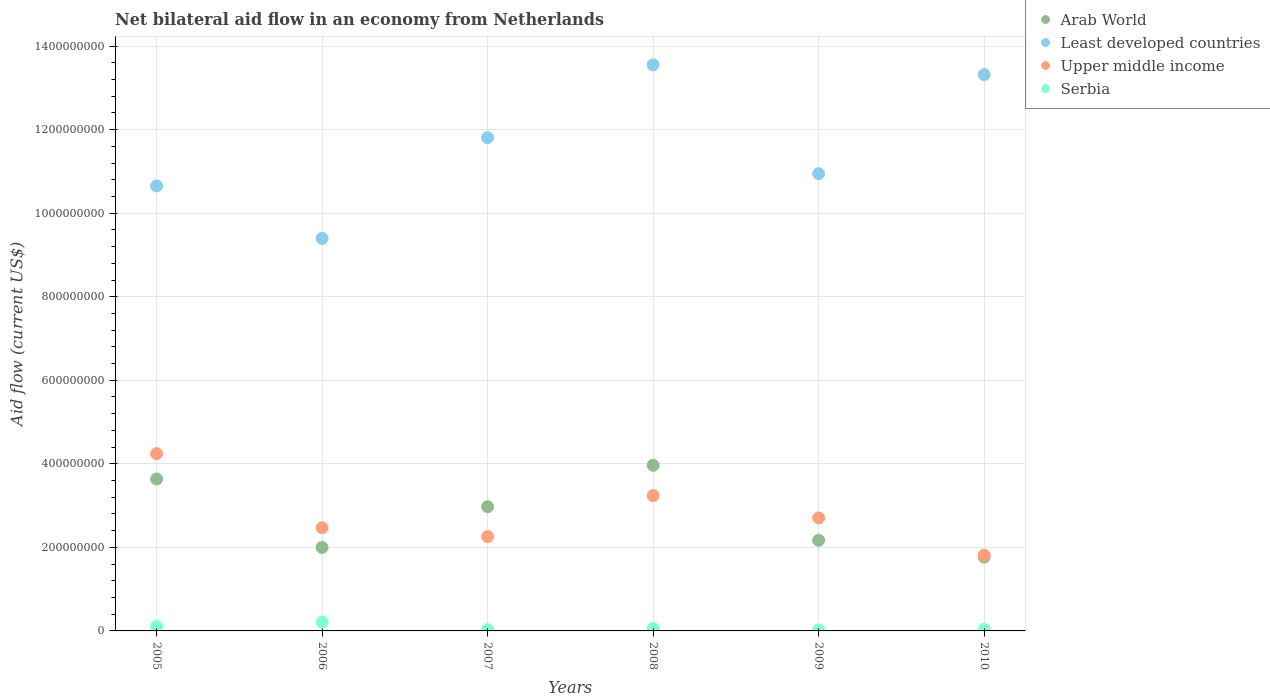Is the number of dotlines equal to the number of legend labels?
Give a very brief answer. Yes. What is the net bilateral aid flow in Serbia in 2005?
Offer a terse response. 1.08e+07. Across all years, what is the maximum net bilateral aid flow in Least developed countries?
Provide a short and direct response. 1.36e+09. Across all years, what is the minimum net bilateral aid flow in Least developed countries?
Offer a very short reply. 9.40e+08. In which year was the net bilateral aid flow in Arab World maximum?
Your response must be concise. 2008. In which year was the net bilateral aid flow in Upper middle income minimum?
Your answer should be compact. 2010. What is the total net bilateral aid flow in Arab World in the graph?
Your answer should be compact. 1.65e+09. What is the difference between the net bilateral aid flow in Least developed countries in 2008 and that in 2009?
Your answer should be compact. 2.61e+08. What is the difference between the net bilateral aid flow in Serbia in 2006 and the net bilateral aid flow in Least developed countries in 2005?
Your answer should be very brief. -1.04e+09. What is the average net bilateral aid flow in Upper middle income per year?
Provide a short and direct response. 2.79e+08. In the year 2007, what is the difference between the net bilateral aid flow in Arab World and net bilateral aid flow in Least developed countries?
Make the answer very short. -8.83e+08. What is the ratio of the net bilateral aid flow in Arab World in 2009 to that in 2010?
Your answer should be compact. 1.23. Is the net bilateral aid flow in Serbia in 2006 less than that in 2007?
Provide a succinct answer. No. Is the difference between the net bilateral aid flow in Arab World in 2008 and 2009 greater than the difference between the net bilateral aid flow in Least developed countries in 2008 and 2009?
Your answer should be very brief. No. What is the difference between the highest and the second highest net bilateral aid flow in Upper middle income?
Offer a very short reply. 1.00e+08. What is the difference between the highest and the lowest net bilateral aid flow in Least developed countries?
Your response must be concise. 4.16e+08. Is the sum of the net bilateral aid flow in Upper middle income in 2007 and 2008 greater than the maximum net bilateral aid flow in Serbia across all years?
Your response must be concise. Yes. Is it the case that in every year, the sum of the net bilateral aid flow in Serbia and net bilateral aid flow in Arab World  is greater than the net bilateral aid flow in Upper middle income?
Offer a very short reply. No. Does the net bilateral aid flow in Serbia monotonically increase over the years?
Provide a short and direct response. No. How many dotlines are there?
Provide a short and direct response. 4. Does the graph contain grids?
Your response must be concise. Yes. Where does the legend appear in the graph?
Offer a very short reply. Top right. How many legend labels are there?
Ensure brevity in your answer.  4. What is the title of the graph?
Your answer should be compact. Net bilateral aid flow in an economy from Netherlands. What is the Aid flow (current US$) of Arab World in 2005?
Your answer should be compact. 3.64e+08. What is the Aid flow (current US$) of Least developed countries in 2005?
Your answer should be very brief. 1.07e+09. What is the Aid flow (current US$) in Upper middle income in 2005?
Your response must be concise. 4.24e+08. What is the Aid flow (current US$) in Serbia in 2005?
Offer a terse response. 1.08e+07. What is the Aid flow (current US$) of Arab World in 2006?
Keep it short and to the point. 2.00e+08. What is the Aid flow (current US$) of Least developed countries in 2006?
Ensure brevity in your answer.  9.40e+08. What is the Aid flow (current US$) of Upper middle income in 2006?
Your answer should be very brief. 2.47e+08. What is the Aid flow (current US$) of Serbia in 2006?
Your response must be concise. 2.13e+07. What is the Aid flow (current US$) in Arab World in 2007?
Ensure brevity in your answer.  2.97e+08. What is the Aid flow (current US$) of Least developed countries in 2007?
Offer a terse response. 1.18e+09. What is the Aid flow (current US$) of Upper middle income in 2007?
Offer a very short reply. 2.26e+08. What is the Aid flow (current US$) of Serbia in 2007?
Your answer should be very brief. 3.11e+06. What is the Aid flow (current US$) in Arab World in 2008?
Offer a terse response. 3.96e+08. What is the Aid flow (current US$) of Least developed countries in 2008?
Your answer should be very brief. 1.36e+09. What is the Aid flow (current US$) of Upper middle income in 2008?
Your answer should be compact. 3.24e+08. What is the Aid flow (current US$) in Serbia in 2008?
Offer a terse response. 6.06e+06. What is the Aid flow (current US$) in Arab World in 2009?
Offer a terse response. 2.17e+08. What is the Aid flow (current US$) of Least developed countries in 2009?
Keep it short and to the point. 1.09e+09. What is the Aid flow (current US$) of Upper middle income in 2009?
Give a very brief answer. 2.71e+08. What is the Aid flow (current US$) of Serbia in 2009?
Provide a succinct answer. 2.62e+06. What is the Aid flow (current US$) of Arab World in 2010?
Your answer should be compact. 1.77e+08. What is the Aid flow (current US$) in Least developed countries in 2010?
Give a very brief answer. 1.33e+09. What is the Aid flow (current US$) of Upper middle income in 2010?
Your answer should be very brief. 1.81e+08. What is the Aid flow (current US$) in Serbia in 2010?
Give a very brief answer. 3.78e+06. Across all years, what is the maximum Aid flow (current US$) in Arab World?
Offer a terse response. 3.96e+08. Across all years, what is the maximum Aid flow (current US$) in Least developed countries?
Your answer should be compact. 1.36e+09. Across all years, what is the maximum Aid flow (current US$) of Upper middle income?
Provide a short and direct response. 4.24e+08. Across all years, what is the maximum Aid flow (current US$) of Serbia?
Offer a very short reply. 2.13e+07. Across all years, what is the minimum Aid flow (current US$) of Arab World?
Offer a terse response. 1.77e+08. Across all years, what is the minimum Aid flow (current US$) in Least developed countries?
Provide a short and direct response. 9.40e+08. Across all years, what is the minimum Aid flow (current US$) in Upper middle income?
Offer a very short reply. 1.81e+08. Across all years, what is the minimum Aid flow (current US$) in Serbia?
Your answer should be very brief. 2.62e+06. What is the total Aid flow (current US$) in Arab World in the graph?
Give a very brief answer. 1.65e+09. What is the total Aid flow (current US$) in Least developed countries in the graph?
Keep it short and to the point. 6.97e+09. What is the total Aid flow (current US$) in Upper middle income in the graph?
Give a very brief answer. 1.67e+09. What is the total Aid flow (current US$) in Serbia in the graph?
Your answer should be compact. 4.76e+07. What is the difference between the Aid flow (current US$) in Arab World in 2005 and that in 2006?
Offer a very short reply. 1.64e+08. What is the difference between the Aid flow (current US$) of Least developed countries in 2005 and that in 2006?
Your answer should be very brief. 1.26e+08. What is the difference between the Aid flow (current US$) in Upper middle income in 2005 and that in 2006?
Make the answer very short. 1.77e+08. What is the difference between the Aid flow (current US$) of Serbia in 2005 and that in 2006?
Your answer should be compact. -1.06e+07. What is the difference between the Aid flow (current US$) in Arab World in 2005 and that in 2007?
Your answer should be very brief. 6.62e+07. What is the difference between the Aid flow (current US$) of Least developed countries in 2005 and that in 2007?
Provide a succinct answer. -1.15e+08. What is the difference between the Aid flow (current US$) in Upper middle income in 2005 and that in 2007?
Your answer should be very brief. 1.99e+08. What is the difference between the Aid flow (current US$) in Serbia in 2005 and that in 2007?
Make the answer very short. 7.64e+06. What is the difference between the Aid flow (current US$) in Arab World in 2005 and that in 2008?
Provide a short and direct response. -3.29e+07. What is the difference between the Aid flow (current US$) of Least developed countries in 2005 and that in 2008?
Offer a very short reply. -2.90e+08. What is the difference between the Aid flow (current US$) in Upper middle income in 2005 and that in 2008?
Make the answer very short. 1.00e+08. What is the difference between the Aid flow (current US$) in Serbia in 2005 and that in 2008?
Ensure brevity in your answer.  4.69e+06. What is the difference between the Aid flow (current US$) in Arab World in 2005 and that in 2009?
Make the answer very short. 1.47e+08. What is the difference between the Aid flow (current US$) in Least developed countries in 2005 and that in 2009?
Your response must be concise. -2.94e+07. What is the difference between the Aid flow (current US$) of Upper middle income in 2005 and that in 2009?
Make the answer very short. 1.54e+08. What is the difference between the Aid flow (current US$) of Serbia in 2005 and that in 2009?
Your response must be concise. 8.13e+06. What is the difference between the Aid flow (current US$) in Arab World in 2005 and that in 2010?
Make the answer very short. 1.87e+08. What is the difference between the Aid flow (current US$) in Least developed countries in 2005 and that in 2010?
Keep it short and to the point. -2.66e+08. What is the difference between the Aid flow (current US$) in Upper middle income in 2005 and that in 2010?
Your answer should be compact. 2.43e+08. What is the difference between the Aid flow (current US$) in Serbia in 2005 and that in 2010?
Your response must be concise. 6.97e+06. What is the difference between the Aid flow (current US$) in Arab World in 2006 and that in 2007?
Provide a succinct answer. -9.76e+07. What is the difference between the Aid flow (current US$) in Least developed countries in 2006 and that in 2007?
Make the answer very short. -2.41e+08. What is the difference between the Aid flow (current US$) of Upper middle income in 2006 and that in 2007?
Your answer should be very brief. 2.12e+07. What is the difference between the Aid flow (current US$) of Serbia in 2006 and that in 2007?
Offer a terse response. 1.82e+07. What is the difference between the Aid flow (current US$) of Arab World in 2006 and that in 2008?
Your answer should be compact. -1.97e+08. What is the difference between the Aid flow (current US$) of Least developed countries in 2006 and that in 2008?
Ensure brevity in your answer.  -4.16e+08. What is the difference between the Aid flow (current US$) in Upper middle income in 2006 and that in 2008?
Your answer should be very brief. -7.70e+07. What is the difference between the Aid flow (current US$) of Serbia in 2006 and that in 2008?
Provide a succinct answer. 1.52e+07. What is the difference between the Aid flow (current US$) in Arab World in 2006 and that in 2009?
Ensure brevity in your answer.  -1.71e+07. What is the difference between the Aid flow (current US$) in Least developed countries in 2006 and that in 2009?
Your response must be concise. -1.55e+08. What is the difference between the Aid flow (current US$) in Upper middle income in 2006 and that in 2009?
Ensure brevity in your answer.  -2.36e+07. What is the difference between the Aid flow (current US$) in Serbia in 2006 and that in 2009?
Ensure brevity in your answer.  1.87e+07. What is the difference between the Aid flow (current US$) in Arab World in 2006 and that in 2010?
Make the answer very short. 2.32e+07. What is the difference between the Aid flow (current US$) in Least developed countries in 2006 and that in 2010?
Offer a very short reply. -3.92e+08. What is the difference between the Aid flow (current US$) in Upper middle income in 2006 and that in 2010?
Provide a succinct answer. 6.58e+07. What is the difference between the Aid flow (current US$) of Serbia in 2006 and that in 2010?
Make the answer very short. 1.75e+07. What is the difference between the Aid flow (current US$) in Arab World in 2007 and that in 2008?
Keep it short and to the point. -9.91e+07. What is the difference between the Aid flow (current US$) in Least developed countries in 2007 and that in 2008?
Give a very brief answer. -1.74e+08. What is the difference between the Aid flow (current US$) of Upper middle income in 2007 and that in 2008?
Offer a very short reply. -9.82e+07. What is the difference between the Aid flow (current US$) in Serbia in 2007 and that in 2008?
Your response must be concise. -2.95e+06. What is the difference between the Aid flow (current US$) of Arab World in 2007 and that in 2009?
Ensure brevity in your answer.  8.05e+07. What is the difference between the Aid flow (current US$) of Least developed countries in 2007 and that in 2009?
Your answer should be compact. 8.61e+07. What is the difference between the Aid flow (current US$) in Upper middle income in 2007 and that in 2009?
Your answer should be very brief. -4.48e+07. What is the difference between the Aid flow (current US$) of Arab World in 2007 and that in 2010?
Make the answer very short. 1.21e+08. What is the difference between the Aid flow (current US$) in Least developed countries in 2007 and that in 2010?
Provide a short and direct response. -1.51e+08. What is the difference between the Aid flow (current US$) in Upper middle income in 2007 and that in 2010?
Your answer should be very brief. 4.46e+07. What is the difference between the Aid flow (current US$) in Serbia in 2007 and that in 2010?
Make the answer very short. -6.70e+05. What is the difference between the Aid flow (current US$) in Arab World in 2008 and that in 2009?
Offer a terse response. 1.80e+08. What is the difference between the Aid flow (current US$) in Least developed countries in 2008 and that in 2009?
Offer a very short reply. 2.61e+08. What is the difference between the Aid flow (current US$) in Upper middle income in 2008 and that in 2009?
Keep it short and to the point. 5.34e+07. What is the difference between the Aid flow (current US$) in Serbia in 2008 and that in 2009?
Your answer should be very brief. 3.44e+06. What is the difference between the Aid flow (current US$) in Arab World in 2008 and that in 2010?
Keep it short and to the point. 2.20e+08. What is the difference between the Aid flow (current US$) of Least developed countries in 2008 and that in 2010?
Provide a short and direct response. 2.34e+07. What is the difference between the Aid flow (current US$) in Upper middle income in 2008 and that in 2010?
Your answer should be compact. 1.43e+08. What is the difference between the Aid flow (current US$) of Serbia in 2008 and that in 2010?
Your answer should be very brief. 2.28e+06. What is the difference between the Aid flow (current US$) in Arab World in 2009 and that in 2010?
Your answer should be very brief. 4.02e+07. What is the difference between the Aid flow (current US$) in Least developed countries in 2009 and that in 2010?
Give a very brief answer. -2.37e+08. What is the difference between the Aid flow (current US$) of Upper middle income in 2009 and that in 2010?
Ensure brevity in your answer.  8.93e+07. What is the difference between the Aid flow (current US$) in Serbia in 2009 and that in 2010?
Provide a short and direct response. -1.16e+06. What is the difference between the Aid flow (current US$) of Arab World in 2005 and the Aid flow (current US$) of Least developed countries in 2006?
Offer a terse response. -5.76e+08. What is the difference between the Aid flow (current US$) of Arab World in 2005 and the Aid flow (current US$) of Upper middle income in 2006?
Keep it short and to the point. 1.17e+08. What is the difference between the Aid flow (current US$) in Arab World in 2005 and the Aid flow (current US$) in Serbia in 2006?
Offer a very short reply. 3.42e+08. What is the difference between the Aid flow (current US$) in Least developed countries in 2005 and the Aid flow (current US$) in Upper middle income in 2006?
Your response must be concise. 8.18e+08. What is the difference between the Aid flow (current US$) in Least developed countries in 2005 and the Aid flow (current US$) in Serbia in 2006?
Ensure brevity in your answer.  1.04e+09. What is the difference between the Aid flow (current US$) of Upper middle income in 2005 and the Aid flow (current US$) of Serbia in 2006?
Offer a terse response. 4.03e+08. What is the difference between the Aid flow (current US$) in Arab World in 2005 and the Aid flow (current US$) in Least developed countries in 2007?
Your response must be concise. -8.17e+08. What is the difference between the Aid flow (current US$) in Arab World in 2005 and the Aid flow (current US$) in Upper middle income in 2007?
Offer a terse response. 1.38e+08. What is the difference between the Aid flow (current US$) of Arab World in 2005 and the Aid flow (current US$) of Serbia in 2007?
Your response must be concise. 3.60e+08. What is the difference between the Aid flow (current US$) of Least developed countries in 2005 and the Aid flow (current US$) of Upper middle income in 2007?
Offer a terse response. 8.39e+08. What is the difference between the Aid flow (current US$) in Least developed countries in 2005 and the Aid flow (current US$) in Serbia in 2007?
Your answer should be very brief. 1.06e+09. What is the difference between the Aid flow (current US$) of Upper middle income in 2005 and the Aid flow (current US$) of Serbia in 2007?
Make the answer very short. 4.21e+08. What is the difference between the Aid flow (current US$) of Arab World in 2005 and the Aid flow (current US$) of Least developed countries in 2008?
Your answer should be compact. -9.92e+08. What is the difference between the Aid flow (current US$) of Arab World in 2005 and the Aid flow (current US$) of Upper middle income in 2008?
Offer a terse response. 3.95e+07. What is the difference between the Aid flow (current US$) of Arab World in 2005 and the Aid flow (current US$) of Serbia in 2008?
Offer a terse response. 3.58e+08. What is the difference between the Aid flow (current US$) in Least developed countries in 2005 and the Aid flow (current US$) in Upper middle income in 2008?
Your answer should be compact. 7.41e+08. What is the difference between the Aid flow (current US$) of Least developed countries in 2005 and the Aid flow (current US$) of Serbia in 2008?
Make the answer very short. 1.06e+09. What is the difference between the Aid flow (current US$) of Upper middle income in 2005 and the Aid flow (current US$) of Serbia in 2008?
Give a very brief answer. 4.18e+08. What is the difference between the Aid flow (current US$) of Arab World in 2005 and the Aid flow (current US$) of Least developed countries in 2009?
Provide a succinct answer. -7.31e+08. What is the difference between the Aid flow (current US$) in Arab World in 2005 and the Aid flow (current US$) in Upper middle income in 2009?
Provide a succinct answer. 9.30e+07. What is the difference between the Aid flow (current US$) of Arab World in 2005 and the Aid flow (current US$) of Serbia in 2009?
Give a very brief answer. 3.61e+08. What is the difference between the Aid flow (current US$) of Least developed countries in 2005 and the Aid flow (current US$) of Upper middle income in 2009?
Offer a terse response. 7.95e+08. What is the difference between the Aid flow (current US$) in Least developed countries in 2005 and the Aid flow (current US$) in Serbia in 2009?
Give a very brief answer. 1.06e+09. What is the difference between the Aid flow (current US$) of Upper middle income in 2005 and the Aid flow (current US$) of Serbia in 2009?
Your answer should be compact. 4.22e+08. What is the difference between the Aid flow (current US$) in Arab World in 2005 and the Aid flow (current US$) in Least developed countries in 2010?
Keep it short and to the point. -9.68e+08. What is the difference between the Aid flow (current US$) in Arab World in 2005 and the Aid flow (current US$) in Upper middle income in 2010?
Make the answer very short. 1.82e+08. What is the difference between the Aid flow (current US$) in Arab World in 2005 and the Aid flow (current US$) in Serbia in 2010?
Your answer should be very brief. 3.60e+08. What is the difference between the Aid flow (current US$) of Least developed countries in 2005 and the Aid flow (current US$) of Upper middle income in 2010?
Ensure brevity in your answer.  8.84e+08. What is the difference between the Aid flow (current US$) in Least developed countries in 2005 and the Aid flow (current US$) in Serbia in 2010?
Offer a terse response. 1.06e+09. What is the difference between the Aid flow (current US$) of Upper middle income in 2005 and the Aid flow (current US$) of Serbia in 2010?
Give a very brief answer. 4.21e+08. What is the difference between the Aid flow (current US$) of Arab World in 2006 and the Aid flow (current US$) of Least developed countries in 2007?
Your answer should be very brief. -9.81e+08. What is the difference between the Aid flow (current US$) of Arab World in 2006 and the Aid flow (current US$) of Upper middle income in 2007?
Make the answer very short. -2.60e+07. What is the difference between the Aid flow (current US$) of Arab World in 2006 and the Aid flow (current US$) of Serbia in 2007?
Ensure brevity in your answer.  1.97e+08. What is the difference between the Aid flow (current US$) of Least developed countries in 2006 and the Aid flow (current US$) of Upper middle income in 2007?
Provide a succinct answer. 7.14e+08. What is the difference between the Aid flow (current US$) of Least developed countries in 2006 and the Aid flow (current US$) of Serbia in 2007?
Provide a short and direct response. 9.36e+08. What is the difference between the Aid flow (current US$) of Upper middle income in 2006 and the Aid flow (current US$) of Serbia in 2007?
Offer a terse response. 2.44e+08. What is the difference between the Aid flow (current US$) in Arab World in 2006 and the Aid flow (current US$) in Least developed countries in 2008?
Your answer should be very brief. -1.16e+09. What is the difference between the Aid flow (current US$) in Arab World in 2006 and the Aid flow (current US$) in Upper middle income in 2008?
Provide a short and direct response. -1.24e+08. What is the difference between the Aid flow (current US$) of Arab World in 2006 and the Aid flow (current US$) of Serbia in 2008?
Give a very brief answer. 1.94e+08. What is the difference between the Aid flow (current US$) in Least developed countries in 2006 and the Aid flow (current US$) in Upper middle income in 2008?
Your response must be concise. 6.15e+08. What is the difference between the Aid flow (current US$) of Least developed countries in 2006 and the Aid flow (current US$) of Serbia in 2008?
Your answer should be very brief. 9.33e+08. What is the difference between the Aid flow (current US$) of Upper middle income in 2006 and the Aid flow (current US$) of Serbia in 2008?
Your answer should be compact. 2.41e+08. What is the difference between the Aid flow (current US$) of Arab World in 2006 and the Aid flow (current US$) of Least developed countries in 2009?
Keep it short and to the point. -8.95e+08. What is the difference between the Aid flow (current US$) in Arab World in 2006 and the Aid flow (current US$) in Upper middle income in 2009?
Give a very brief answer. -7.08e+07. What is the difference between the Aid flow (current US$) of Arab World in 2006 and the Aid flow (current US$) of Serbia in 2009?
Your answer should be very brief. 1.97e+08. What is the difference between the Aid flow (current US$) in Least developed countries in 2006 and the Aid flow (current US$) in Upper middle income in 2009?
Your response must be concise. 6.69e+08. What is the difference between the Aid flow (current US$) in Least developed countries in 2006 and the Aid flow (current US$) in Serbia in 2009?
Offer a terse response. 9.37e+08. What is the difference between the Aid flow (current US$) in Upper middle income in 2006 and the Aid flow (current US$) in Serbia in 2009?
Provide a succinct answer. 2.44e+08. What is the difference between the Aid flow (current US$) of Arab World in 2006 and the Aid flow (current US$) of Least developed countries in 2010?
Offer a very short reply. -1.13e+09. What is the difference between the Aid flow (current US$) in Arab World in 2006 and the Aid flow (current US$) in Upper middle income in 2010?
Offer a very short reply. 1.85e+07. What is the difference between the Aid flow (current US$) of Arab World in 2006 and the Aid flow (current US$) of Serbia in 2010?
Offer a terse response. 1.96e+08. What is the difference between the Aid flow (current US$) in Least developed countries in 2006 and the Aid flow (current US$) in Upper middle income in 2010?
Your response must be concise. 7.58e+08. What is the difference between the Aid flow (current US$) of Least developed countries in 2006 and the Aid flow (current US$) of Serbia in 2010?
Provide a short and direct response. 9.36e+08. What is the difference between the Aid flow (current US$) in Upper middle income in 2006 and the Aid flow (current US$) in Serbia in 2010?
Ensure brevity in your answer.  2.43e+08. What is the difference between the Aid flow (current US$) of Arab World in 2007 and the Aid flow (current US$) of Least developed countries in 2008?
Ensure brevity in your answer.  -1.06e+09. What is the difference between the Aid flow (current US$) of Arab World in 2007 and the Aid flow (current US$) of Upper middle income in 2008?
Your response must be concise. -2.67e+07. What is the difference between the Aid flow (current US$) of Arab World in 2007 and the Aid flow (current US$) of Serbia in 2008?
Offer a very short reply. 2.91e+08. What is the difference between the Aid flow (current US$) in Least developed countries in 2007 and the Aid flow (current US$) in Upper middle income in 2008?
Keep it short and to the point. 8.57e+08. What is the difference between the Aid flow (current US$) in Least developed countries in 2007 and the Aid flow (current US$) in Serbia in 2008?
Provide a succinct answer. 1.17e+09. What is the difference between the Aid flow (current US$) in Upper middle income in 2007 and the Aid flow (current US$) in Serbia in 2008?
Your answer should be very brief. 2.20e+08. What is the difference between the Aid flow (current US$) of Arab World in 2007 and the Aid flow (current US$) of Least developed countries in 2009?
Offer a terse response. -7.97e+08. What is the difference between the Aid flow (current US$) in Arab World in 2007 and the Aid flow (current US$) in Upper middle income in 2009?
Your answer should be very brief. 2.68e+07. What is the difference between the Aid flow (current US$) in Arab World in 2007 and the Aid flow (current US$) in Serbia in 2009?
Keep it short and to the point. 2.95e+08. What is the difference between the Aid flow (current US$) in Least developed countries in 2007 and the Aid flow (current US$) in Upper middle income in 2009?
Provide a succinct answer. 9.10e+08. What is the difference between the Aid flow (current US$) in Least developed countries in 2007 and the Aid flow (current US$) in Serbia in 2009?
Your answer should be very brief. 1.18e+09. What is the difference between the Aid flow (current US$) of Upper middle income in 2007 and the Aid flow (current US$) of Serbia in 2009?
Provide a succinct answer. 2.23e+08. What is the difference between the Aid flow (current US$) of Arab World in 2007 and the Aid flow (current US$) of Least developed countries in 2010?
Provide a short and direct response. -1.03e+09. What is the difference between the Aid flow (current US$) of Arab World in 2007 and the Aid flow (current US$) of Upper middle income in 2010?
Provide a succinct answer. 1.16e+08. What is the difference between the Aid flow (current US$) of Arab World in 2007 and the Aid flow (current US$) of Serbia in 2010?
Make the answer very short. 2.94e+08. What is the difference between the Aid flow (current US$) of Least developed countries in 2007 and the Aid flow (current US$) of Upper middle income in 2010?
Give a very brief answer. 9.99e+08. What is the difference between the Aid flow (current US$) in Least developed countries in 2007 and the Aid flow (current US$) in Serbia in 2010?
Provide a short and direct response. 1.18e+09. What is the difference between the Aid flow (current US$) of Upper middle income in 2007 and the Aid flow (current US$) of Serbia in 2010?
Your answer should be very brief. 2.22e+08. What is the difference between the Aid flow (current US$) of Arab World in 2008 and the Aid flow (current US$) of Least developed countries in 2009?
Ensure brevity in your answer.  -6.98e+08. What is the difference between the Aid flow (current US$) of Arab World in 2008 and the Aid flow (current US$) of Upper middle income in 2009?
Your answer should be very brief. 1.26e+08. What is the difference between the Aid flow (current US$) in Arab World in 2008 and the Aid flow (current US$) in Serbia in 2009?
Offer a very short reply. 3.94e+08. What is the difference between the Aid flow (current US$) in Least developed countries in 2008 and the Aid flow (current US$) in Upper middle income in 2009?
Provide a succinct answer. 1.08e+09. What is the difference between the Aid flow (current US$) in Least developed countries in 2008 and the Aid flow (current US$) in Serbia in 2009?
Ensure brevity in your answer.  1.35e+09. What is the difference between the Aid flow (current US$) of Upper middle income in 2008 and the Aid flow (current US$) of Serbia in 2009?
Your answer should be very brief. 3.21e+08. What is the difference between the Aid flow (current US$) of Arab World in 2008 and the Aid flow (current US$) of Least developed countries in 2010?
Your response must be concise. -9.35e+08. What is the difference between the Aid flow (current US$) in Arab World in 2008 and the Aid flow (current US$) in Upper middle income in 2010?
Provide a short and direct response. 2.15e+08. What is the difference between the Aid flow (current US$) of Arab World in 2008 and the Aid flow (current US$) of Serbia in 2010?
Provide a succinct answer. 3.93e+08. What is the difference between the Aid flow (current US$) in Least developed countries in 2008 and the Aid flow (current US$) in Upper middle income in 2010?
Provide a succinct answer. 1.17e+09. What is the difference between the Aid flow (current US$) of Least developed countries in 2008 and the Aid flow (current US$) of Serbia in 2010?
Your response must be concise. 1.35e+09. What is the difference between the Aid flow (current US$) in Upper middle income in 2008 and the Aid flow (current US$) in Serbia in 2010?
Offer a very short reply. 3.20e+08. What is the difference between the Aid flow (current US$) of Arab World in 2009 and the Aid flow (current US$) of Least developed countries in 2010?
Your response must be concise. -1.11e+09. What is the difference between the Aid flow (current US$) in Arab World in 2009 and the Aid flow (current US$) in Upper middle income in 2010?
Make the answer very short. 3.56e+07. What is the difference between the Aid flow (current US$) of Arab World in 2009 and the Aid flow (current US$) of Serbia in 2010?
Offer a terse response. 2.13e+08. What is the difference between the Aid flow (current US$) of Least developed countries in 2009 and the Aid flow (current US$) of Upper middle income in 2010?
Give a very brief answer. 9.13e+08. What is the difference between the Aid flow (current US$) in Least developed countries in 2009 and the Aid flow (current US$) in Serbia in 2010?
Keep it short and to the point. 1.09e+09. What is the difference between the Aid flow (current US$) in Upper middle income in 2009 and the Aid flow (current US$) in Serbia in 2010?
Make the answer very short. 2.67e+08. What is the average Aid flow (current US$) of Arab World per year?
Your answer should be compact. 2.75e+08. What is the average Aid flow (current US$) of Least developed countries per year?
Make the answer very short. 1.16e+09. What is the average Aid flow (current US$) in Upper middle income per year?
Offer a terse response. 2.79e+08. What is the average Aid flow (current US$) in Serbia per year?
Ensure brevity in your answer.  7.94e+06. In the year 2005, what is the difference between the Aid flow (current US$) in Arab World and Aid flow (current US$) in Least developed countries?
Your answer should be compact. -7.02e+08. In the year 2005, what is the difference between the Aid flow (current US$) of Arab World and Aid flow (current US$) of Upper middle income?
Your answer should be very brief. -6.08e+07. In the year 2005, what is the difference between the Aid flow (current US$) in Arab World and Aid flow (current US$) in Serbia?
Give a very brief answer. 3.53e+08. In the year 2005, what is the difference between the Aid flow (current US$) in Least developed countries and Aid flow (current US$) in Upper middle income?
Provide a succinct answer. 6.41e+08. In the year 2005, what is the difference between the Aid flow (current US$) in Least developed countries and Aid flow (current US$) in Serbia?
Provide a short and direct response. 1.05e+09. In the year 2005, what is the difference between the Aid flow (current US$) in Upper middle income and Aid flow (current US$) in Serbia?
Offer a very short reply. 4.14e+08. In the year 2006, what is the difference between the Aid flow (current US$) of Arab World and Aid flow (current US$) of Least developed countries?
Offer a terse response. -7.40e+08. In the year 2006, what is the difference between the Aid flow (current US$) in Arab World and Aid flow (current US$) in Upper middle income?
Your response must be concise. -4.72e+07. In the year 2006, what is the difference between the Aid flow (current US$) of Arab World and Aid flow (current US$) of Serbia?
Provide a short and direct response. 1.79e+08. In the year 2006, what is the difference between the Aid flow (current US$) of Least developed countries and Aid flow (current US$) of Upper middle income?
Ensure brevity in your answer.  6.92e+08. In the year 2006, what is the difference between the Aid flow (current US$) in Least developed countries and Aid flow (current US$) in Serbia?
Offer a terse response. 9.18e+08. In the year 2006, what is the difference between the Aid flow (current US$) of Upper middle income and Aid flow (current US$) of Serbia?
Provide a short and direct response. 2.26e+08. In the year 2007, what is the difference between the Aid flow (current US$) of Arab World and Aid flow (current US$) of Least developed countries?
Offer a terse response. -8.83e+08. In the year 2007, what is the difference between the Aid flow (current US$) of Arab World and Aid flow (current US$) of Upper middle income?
Keep it short and to the point. 7.16e+07. In the year 2007, what is the difference between the Aid flow (current US$) in Arab World and Aid flow (current US$) in Serbia?
Provide a short and direct response. 2.94e+08. In the year 2007, what is the difference between the Aid flow (current US$) of Least developed countries and Aid flow (current US$) of Upper middle income?
Offer a very short reply. 9.55e+08. In the year 2007, what is the difference between the Aid flow (current US$) in Least developed countries and Aid flow (current US$) in Serbia?
Provide a succinct answer. 1.18e+09. In the year 2007, what is the difference between the Aid flow (current US$) of Upper middle income and Aid flow (current US$) of Serbia?
Make the answer very short. 2.23e+08. In the year 2008, what is the difference between the Aid flow (current US$) in Arab World and Aid flow (current US$) in Least developed countries?
Give a very brief answer. -9.59e+08. In the year 2008, what is the difference between the Aid flow (current US$) of Arab World and Aid flow (current US$) of Upper middle income?
Give a very brief answer. 7.24e+07. In the year 2008, what is the difference between the Aid flow (current US$) of Arab World and Aid flow (current US$) of Serbia?
Provide a short and direct response. 3.90e+08. In the year 2008, what is the difference between the Aid flow (current US$) in Least developed countries and Aid flow (current US$) in Upper middle income?
Provide a short and direct response. 1.03e+09. In the year 2008, what is the difference between the Aid flow (current US$) in Least developed countries and Aid flow (current US$) in Serbia?
Offer a very short reply. 1.35e+09. In the year 2008, what is the difference between the Aid flow (current US$) of Upper middle income and Aid flow (current US$) of Serbia?
Your answer should be very brief. 3.18e+08. In the year 2009, what is the difference between the Aid flow (current US$) in Arab World and Aid flow (current US$) in Least developed countries?
Your response must be concise. -8.78e+08. In the year 2009, what is the difference between the Aid flow (current US$) in Arab World and Aid flow (current US$) in Upper middle income?
Your answer should be very brief. -5.37e+07. In the year 2009, what is the difference between the Aid flow (current US$) in Arab World and Aid flow (current US$) in Serbia?
Your answer should be compact. 2.14e+08. In the year 2009, what is the difference between the Aid flow (current US$) in Least developed countries and Aid flow (current US$) in Upper middle income?
Your response must be concise. 8.24e+08. In the year 2009, what is the difference between the Aid flow (current US$) in Least developed countries and Aid flow (current US$) in Serbia?
Keep it short and to the point. 1.09e+09. In the year 2009, what is the difference between the Aid flow (current US$) in Upper middle income and Aid flow (current US$) in Serbia?
Provide a short and direct response. 2.68e+08. In the year 2010, what is the difference between the Aid flow (current US$) of Arab World and Aid flow (current US$) of Least developed countries?
Your answer should be compact. -1.16e+09. In the year 2010, what is the difference between the Aid flow (current US$) in Arab World and Aid flow (current US$) in Upper middle income?
Make the answer very short. -4.62e+06. In the year 2010, what is the difference between the Aid flow (current US$) in Arab World and Aid flow (current US$) in Serbia?
Make the answer very short. 1.73e+08. In the year 2010, what is the difference between the Aid flow (current US$) in Least developed countries and Aid flow (current US$) in Upper middle income?
Provide a succinct answer. 1.15e+09. In the year 2010, what is the difference between the Aid flow (current US$) of Least developed countries and Aid flow (current US$) of Serbia?
Your answer should be compact. 1.33e+09. In the year 2010, what is the difference between the Aid flow (current US$) in Upper middle income and Aid flow (current US$) in Serbia?
Your answer should be compact. 1.77e+08. What is the ratio of the Aid flow (current US$) of Arab World in 2005 to that in 2006?
Ensure brevity in your answer.  1.82. What is the ratio of the Aid flow (current US$) of Least developed countries in 2005 to that in 2006?
Provide a short and direct response. 1.13. What is the ratio of the Aid flow (current US$) of Upper middle income in 2005 to that in 2006?
Offer a terse response. 1.72. What is the ratio of the Aid flow (current US$) in Serbia in 2005 to that in 2006?
Provide a succinct answer. 0.5. What is the ratio of the Aid flow (current US$) of Arab World in 2005 to that in 2007?
Provide a short and direct response. 1.22. What is the ratio of the Aid flow (current US$) of Least developed countries in 2005 to that in 2007?
Provide a short and direct response. 0.9. What is the ratio of the Aid flow (current US$) of Upper middle income in 2005 to that in 2007?
Provide a succinct answer. 1.88. What is the ratio of the Aid flow (current US$) of Serbia in 2005 to that in 2007?
Your answer should be very brief. 3.46. What is the ratio of the Aid flow (current US$) of Arab World in 2005 to that in 2008?
Your answer should be very brief. 0.92. What is the ratio of the Aid flow (current US$) of Least developed countries in 2005 to that in 2008?
Give a very brief answer. 0.79. What is the ratio of the Aid flow (current US$) of Upper middle income in 2005 to that in 2008?
Keep it short and to the point. 1.31. What is the ratio of the Aid flow (current US$) in Serbia in 2005 to that in 2008?
Provide a short and direct response. 1.77. What is the ratio of the Aid flow (current US$) in Arab World in 2005 to that in 2009?
Your response must be concise. 1.68. What is the ratio of the Aid flow (current US$) in Least developed countries in 2005 to that in 2009?
Provide a short and direct response. 0.97. What is the ratio of the Aid flow (current US$) of Upper middle income in 2005 to that in 2009?
Your answer should be very brief. 1.57. What is the ratio of the Aid flow (current US$) of Serbia in 2005 to that in 2009?
Make the answer very short. 4.1. What is the ratio of the Aid flow (current US$) in Arab World in 2005 to that in 2010?
Ensure brevity in your answer.  2.06. What is the ratio of the Aid flow (current US$) in Least developed countries in 2005 to that in 2010?
Ensure brevity in your answer.  0.8. What is the ratio of the Aid flow (current US$) in Upper middle income in 2005 to that in 2010?
Your response must be concise. 2.34. What is the ratio of the Aid flow (current US$) in Serbia in 2005 to that in 2010?
Your answer should be very brief. 2.84. What is the ratio of the Aid flow (current US$) in Arab World in 2006 to that in 2007?
Make the answer very short. 0.67. What is the ratio of the Aid flow (current US$) of Least developed countries in 2006 to that in 2007?
Keep it short and to the point. 0.8. What is the ratio of the Aid flow (current US$) of Upper middle income in 2006 to that in 2007?
Ensure brevity in your answer.  1.09. What is the ratio of the Aid flow (current US$) in Serbia in 2006 to that in 2007?
Provide a short and direct response. 6.85. What is the ratio of the Aid flow (current US$) of Arab World in 2006 to that in 2008?
Your answer should be compact. 0.5. What is the ratio of the Aid flow (current US$) in Least developed countries in 2006 to that in 2008?
Provide a short and direct response. 0.69. What is the ratio of the Aid flow (current US$) in Upper middle income in 2006 to that in 2008?
Your answer should be very brief. 0.76. What is the ratio of the Aid flow (current US$) of Serbia in 2006 to that in 2008?
Your response must be concise. 3.51. What is the ratio of the Aid flow (current US$) of Arab World in 2006 to that in 2009?
Your response must be concise. 0.92. What is the ratio of the Aid flow (current US$) of Least developed countries in 2006 to that in 2009?
Give a very brief answer. 0.86. What is the ratio of the Aid flow (current US$) in Upper middle income in 2006 to that in 2009?
Make the answer very short. 0.91. What is the ratio of the Aid flow (current US$) in Serbia in 2006 to that in 2009?
Provide a short and direct response. 8.13. What is the ratio of the Aid flow (current US$) in Arab World in 2006 to that in 2010?
Offer a terse response. 1.13. What is the ratio of the Aid flow (current US$) in Least developed countries in 2006 to that in 2010?
Give a very brief answer. 0.71. What is the ratio of the Aid flow (current US$) in Upper middle income in 2006 to that in 2010?
Your response must be concise. 1.36. What is the ratio of the Aid flow (current US$) of Serbia in 2006 to that in 2010?
Ensure brevity in your answer.  5.63. What is the ratio of the Aid flow (current US$) of Least developed countries in 2007 to that in 2008?
Make the answer very short. 0.87. What is the ratio of the Aid flow (current US$) in Upper middle income in 2007 to that in 2008?
Your answer should be compact. 0.7. What is the ratio of the Aid flow (current US$) of Serbia in 2007 to that in 2008?
Your answer should be compact. 0.51. What is the ratio of the Aid flow (current US$) in Arab World in 2007 to that in 2009?
Ensure brevity in your answer.  1.37. What is the ratio of the Aid flow (current US$) in Least developed countries in 2007 to that in 2009?
Offer a very short reply. 1.08. What is the ratio of the Aid flow (current US$) in Upper middle income in 2007 to that in 2009?
Ensure brevity in your answer.  0.83. What is the ratio of the Aid flow (current US$) of Serbia in 2007 to that in 2009?
Make the answer very short. 1.19. What is the ratio of the Aid flow (current US$) in Arab World in 2007 to that in 2010?
Your response must be concise. 1.68. What is the ratio of the Aid flow (current US$) of Least developed countries in 2007 to that in 2010?
Offer a terse response. 0.89. What is the ratio of the Aid flow (current US$) of Upper middle income in 2007 to that in 2010?
Ensure brevity in your answer.  1.25. What is the ratio of the Aid flow (current US$) in Serbia in 2007 to that in 2010?
Your response must be concise. 0.82. What is the ratio of the Aid flow (current US$) in Arab World in 2008 to that in 2009?
Give a very brief answer. 1.83. What is the ratio of the Aid flow (current US$) of Least developed countries in 2008 to that in 2009?
Ensure brevity in your answer.  1.24. What is the ratio of the Aid flow (current US$) in Upper middle income in 2008 to that in 2009?
Provide a succinct answer. 1.2. What is the ratio of the Aid flow (current US$) in Serbia in 2008 to that in 2009?
Provide a succinct answer. 2.31. What is the ratio of the Aid flow (current US$) in Arab World in 2008 to that in 2010?
Your response must be concise. 2.24. What is the ratio of the Aid flow (current US$) of Least developed countries in 2008 to that in 2010?
Make the answer very short. 1.02. What is the ratio of the Aid flow (current US$) of Upper middle income in 2008 to that in 2010?
Make the answer very short. 1.79. What is the ratio of the Aid flow (current US$) in Serbia in 2008 to that in 2010?
Keep it short and to the point. 1.6. What is the ratio of the Aid flow (current US$) of Arab World in 2009 to that in 2010?
Ensure brevity in your answer.  1.23. What is the ratio of the Aid flow (current US$) in Least developed countries in 2009 to that in 2010?
Offer a terse response. 0.82. What is the ratio of the Aid flow (current US$) in Upper middle income in 2009 to that in 2010?
Your answer should be compact. 1.49. What is the ratio of the Aid flow (current US$) of Serbia in 2009 to that in 2010?
Your answer should be very brief. 0.69. What is the difference between the highest and the second highest Aid flow (current US$) in Arab World?
Give a very brief answer. 3.29e+07. What is the difference between the highest and the second highest Aid flow (current US$) of Least developed countries?
Offer a terse response. 2.34e+07. What is the difference between the highest and the second highest Aid flow (current US$) of Upper middle income?
Keep it short and to the point. 1.00e+08. What is the difference between the highest and the second highest Aid flow (current US$) of Serbia?
Give a very brief answer. 1.06e+07. What is the difference between the highest and the lowest Aid flow (current US$) of Arab World?
Keep it short and to the point. 2.20e+08. What is the difference between the highest and the lowest Aid flow (current US$) of Least developed countries?
Your answer should be very brief. 4.16e+08. What is the difference between the highest and the lowest Aid flow (current US$) of Upper middle income?
Provide a short and direct response. 2.43e+08. What is the difference between the highest and the lowest Aid flow (current US$) in Serbia?
Give a very brief answer. 1.87e+07. 